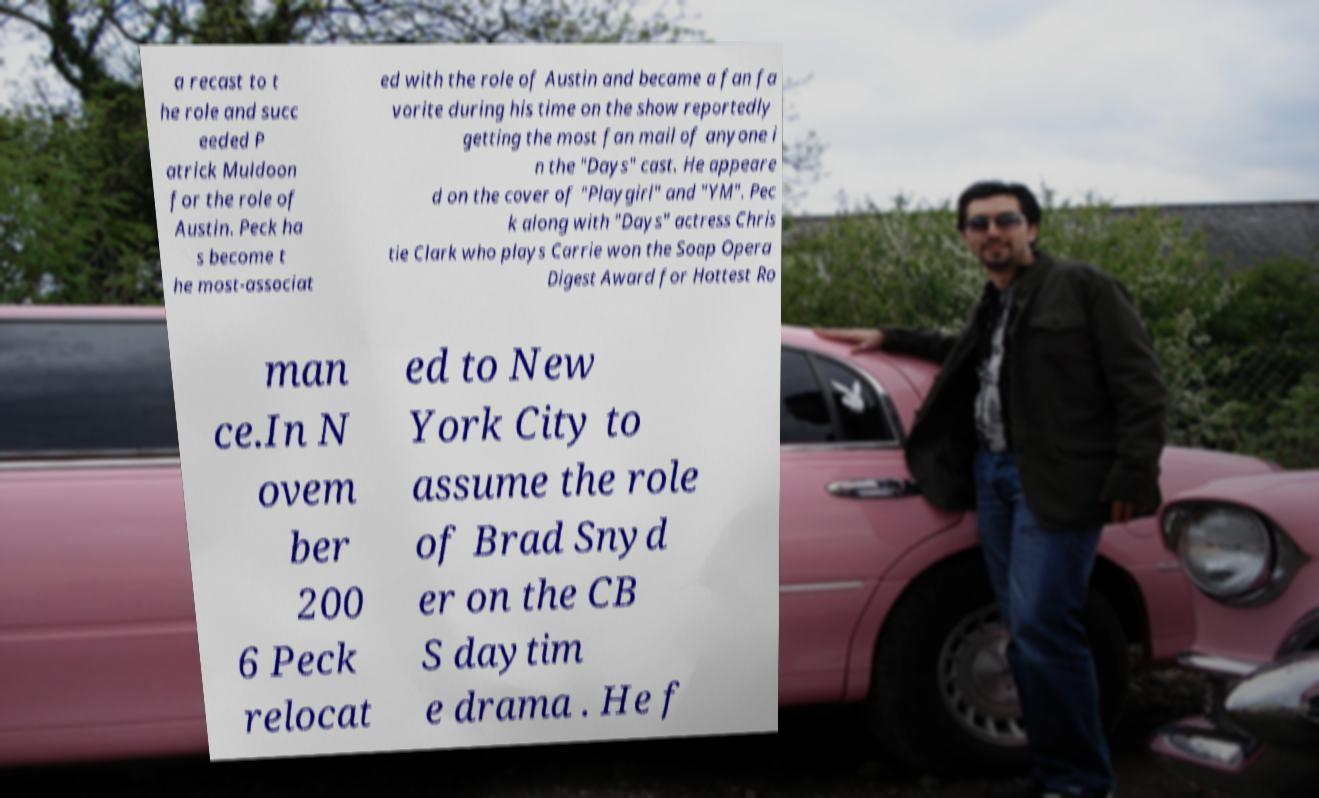Can you read and provide the text displayed in the image?This photo seems to have some interesting text. Can you extract and type it out for me? a recast to t he role and succ eeded P atrick Muldoon for the role of Austin. Peck ha s become t he most-associat ed with the role of Austin and became a fan fa vorite during his time on the show reportedly getting the most fan mail of anyone i n the "Days" cast. He appeare d on the cover of "Playgirl" and "YM". Pec k along with "Days" actress Chris tie Clark who plays Carrie won the Soap Opera Digest Award for Hottest Ro man ce.In N ovem ber 200 6 Peck relocat ed to New York City to assume the role of Brad Snyd er on the CB S daytim e drama . He f 